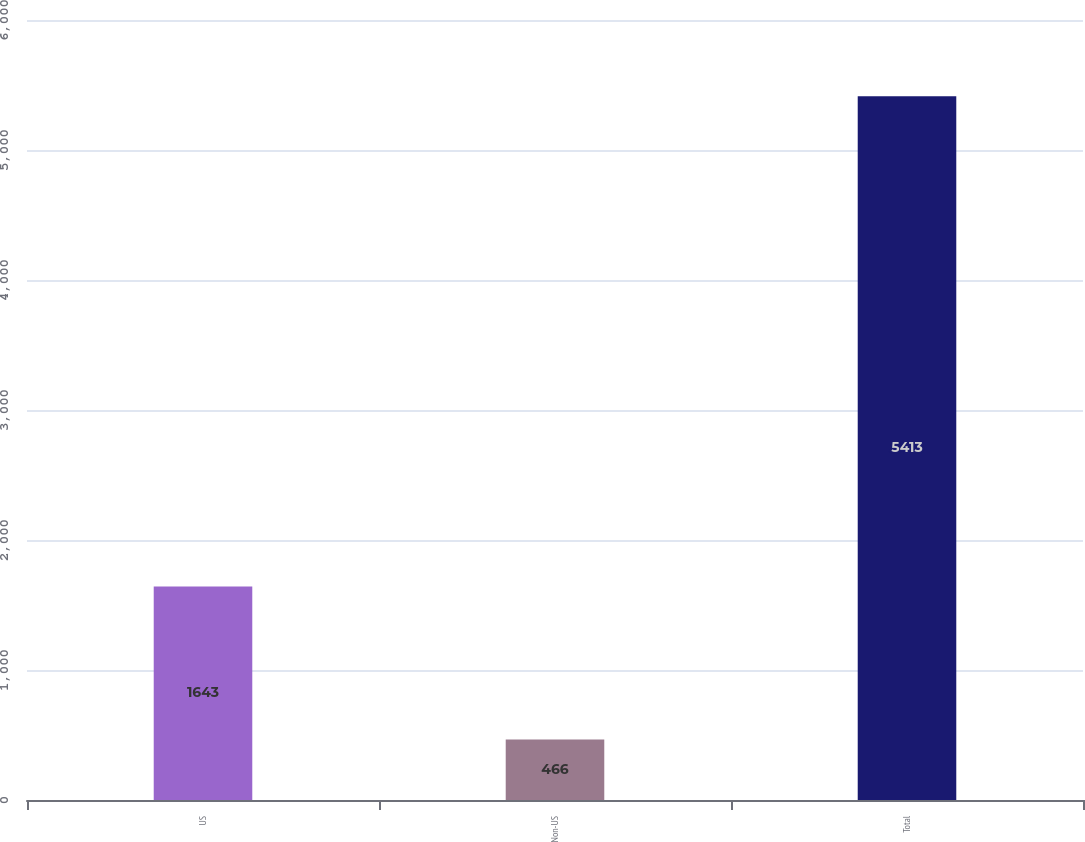Convert chart. <chart><loc_0><loc_0><loc_500><loc_500><bar_chart><fcel>US<fcel>Non-US<fcel>Total<nl><fcel>1643<fcel>466<fcel>5413<nl></chart> 